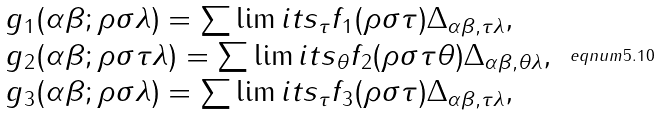Convert formula to latex. <formula><loc_0><loc_0><loc_500><loc_500>\begin{array} { l } g _ { 1 } ( \alpha \beta ; \rho \sigma \lambda ) = \sum \lim i t s _ { \tau } f _ { 1 } ( \rho \sigma \tau ) \Delta _ { \alpha \beta , \tau \lambda } , \\ g _ { 2 } ( \alpha \beta ; \rho \sigma \tau \lambda ) = \sum \lim i t s _ { \theta } f _ { 2 } ( \rho \sigma \tau \theta ) \Delta _ { \alpha \beta , \theta \lambda } , \\ g _ { 3 } ( \alpha \beta ; \rho \sigma \lambda ) = \sum \lim i t s _ { \tau } f _ { 3 } ( \rho \sigma \tau ) \Delta _ { \alpha \beta , \tau \lambda } , \end{array} \ e q n u m { 5 . 1 0 }</formula> 